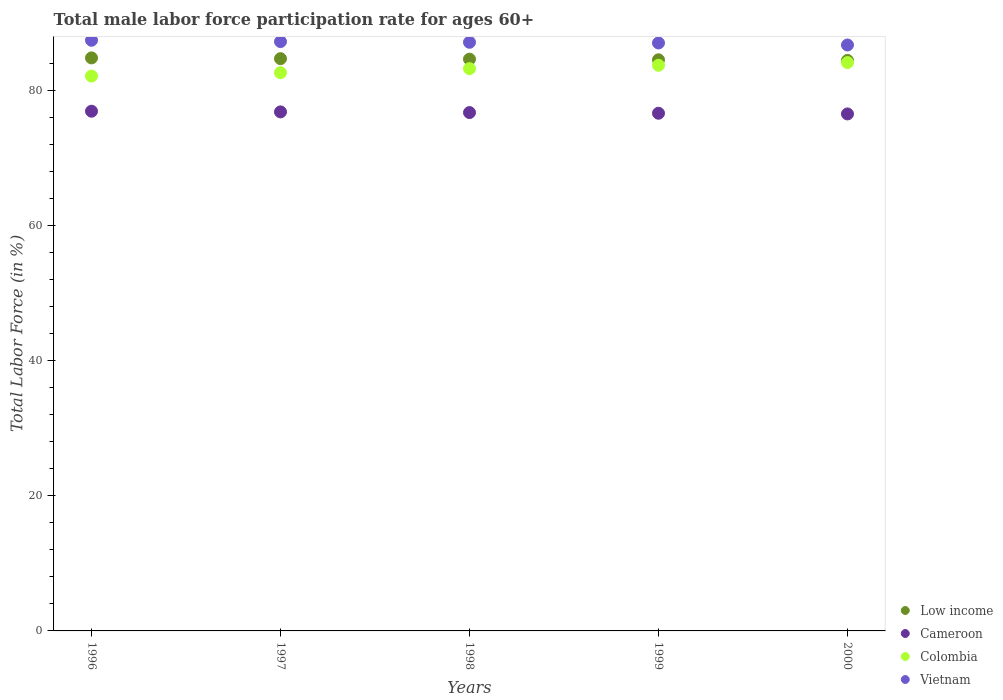How many different coloured dotlines are there?
Your answer should be compact. 4. What is the male labor force participation rate in Vietnam in 2000?
Keep it short and to the point. 86.7. Across all years, what is the maximum male labor force participation rate in Colombia?
Keep it short and to the point. 84.1. Across all years, what is the minimum male labor force participation rate in Vietnam?
Keep it short and to the point. 86.7. In which year was the male labor force participation rate in Low income maximum?
Your answer should be very brief. 1996. In which year was the male labor force participation rate in Cameroon minimum?
Ensure brevity in your answer.  2000. What is the total male labor force participation rate in Cameroon in the graph?
Ensure brevity in your answer.  383.5. What is the difference between the male labor force participation rate in Vietnam in 1997 and that in 1998?
Provide a short and direct response. 0.1. What is the difference between the male labor force participation rate in Vietnam in 1999 and the male labor force participation rate in Cameroon in 1996?
Give a very brief answer. 10.1. What is the average male labor force participation rate in Vietnam per year?
Your answer should be very brief. 87.08. In the year 1996, what is the difference between the male labor force participation rate in Low income and male labor force participation rate in Colombia?
Your answer should be compact. 2.69. What is the ratio of the male labor force participation rate in Low income in 1999 to that in 2000?
Offer a terse response. 1. Is the male labor force participation rate in Vietnam in 1996 less than that in 1999?
Make the answer very short. No. Is the difference between the male labor force participation rate in Low income in 1996 and 1999 greater than the difference between the male labor force participation rate in Colombia in 1996 and 1999?
Offer a very short reply. Yes. What is the difference between the highest and the second highest male labor force participation rate in Low income?
Keep it short and to the point. 0.11. What is the difference between the highest and the lowest male labor force participation rate in Vietnam?
Make the answer very short. 0.7. In how many years, is the male labor force participation rate in Vietnam greater than the average male labor force participation rate in Vietnam taken over all years?
Offer a terse response. 3. Is it the case that in every year, the sum of the male labor force participation rate in Low income and male labor force participation rate in Vietnam  is greater than the sum of male labor force participation rate in Cameroon and male labor force participation rate in Colombia?
Give a very brief answer. Yes. Does the male labor force participation rate in Vietnam monotonically increase over the years?
Make the answer very short. No. Is the male labor force participation rate in Colombia strictly less than the male labor force participation rate in Cameroon over the years?
Your answer should be compact. No. How many years are there in the graph?
Your answer should be very brief. 5. What is the difference between two consecutive major ticks on the Y-axis?
Offer a terse response. 20. Are the values on the major ticks of Y-axis written in scientific E-notation?
Offer a very short reply. No. Does the graph contain any zero values?
Offer a very short reply. No. Does the graph contain grids?
Provide a succinct answer. No. Where does the legend appear in the graph?
Keep it short and to the point. Bottom right. How many legend labels are there?
Offer a terse response. 4. How are the legend labels stacked?
Your answer should be very brief. Vertical. What is the title of the graph?
Provide a succinct answer. Total male labor force participation rate for ages 60+. Does "Guinea" appear as one of the legend labels in the graph?
Provide a succinct answer. No. What is the label or title of the Y-axis?
Offer a very short reply. Total Labor Force (in %). What is the Total Labor Force (in %) in Low income in 1996?
Ensure brevity in your answer.  84.79. What is the Total Labor Force (in %) of Cameroon in 1996?
Keep it short and to the point. 76.9. What is the Total Labor Force (in %) in Colombia in 1996?
Offer a terse response. 82.1. What is the Total Labor Force (in %) in Vietnam in 1996?
Give a very brief answer. 87.4. What is the Total Labor Force (in %) in Low income in 1997?
Your answer should be very brief. 84.68. What is the Total Labor Force (in %) of Cameroon in 1997?
Offer a very short reply. 76.8. What is the Total Labor Force (in %) of Colombia in 1997?
Provide a short and direct response. 82.6. What is the Total Labor Force (in %) in Vietnam in 1997?
Offer a terse response. 87.2. What is the Total Labor Force (in %) of Low income in 1998?
Keep it short and to the point. 84.6. What is the Total Labor Force (in %) of Cameroon in 1998?
Make the answer very short. 76.7. What is the Total Labor Force (in %) in Colombia in 1998?
Provide a succinct answer. 83.2. What is the Total Labor Force (in %) of Vietnam in 1998?
Give a very brief answer. 87.1. What is the Total Labor Force (in %) of Low income in 1999?
Ensure brevity in your answer.  84.51. What is the Total Labor Force (in %) in Cameroon in 1999?
Provide a short and direct response. 76.6. What is the Total Labor Force (in %) in Colombia in 1999?
Provide a short and direct response. 83.7. What is the Total Labor Force (in %) in Low income in 2000?
Provide a short and direct response. 84.42. What is the Total Labor Force (in %) of Cameroon in 2000?
Your answer should be very brief. 76.5. What is the Total Labor Force (in %) of Colombia in 2000?
Your answer should be compact. 84.1. What is the Total Labor Force (in %) of Vietnam in 2000?
Keep it short and to the point. 86.7. Across all years, what is the maximum Total Labor Force (in %) in Low income?
Your answer should be compact. 84.79. Across all years, what is the maximum Total Labor Force (in %) in Cameroon?
Your answer should be compact. 76.9. Across all years, what is the maximum Total Labor Force (in %) in Colombia?
Your answer should be compact. 84.1. Across all years, what is the maximum Total Labor Force (in %) of Vietnam?
Make the answer very short. 87.4. Across all years, what is the minimum Total Labor Force (in %) in Low income?
Your response must be concise. 84.42. Across all years, what is the minimum Total Labor Force (in %) of Cameroon?
Your response must be concise. 76.5. Across all years, what is the minimum Total Labor Force (in %) of Colombia?
Give a very brief answer. 82.1. Across all years, what is the minimum Total Labor Force (in %) of Vietnam?
Offer a terse response. 86.7. What is the total Total Labor Force (in %) of Low income in the graph?
Keep it short and to the point. 423. What is the total Total Labor Force (in %) of Cameroon in the graph?
Provide a succinct answer. 383.5. What is the total Total Labor Force (in %) in Colombia in the graph?
Offer a terse response. 415.7. What is the total Total Labor Force (in %) in Vietnam in the graph?
Make the answer very short. 435.4. What is the difference between the Total Labor Force (in %) in Low income in 1996 and that in 1997?
Provide a succinct answer. 0.11. What is the difference between the Total Labor Force (in %) of Cameroon in 1996 and that in 1997?
Make the answer very short. 0.1. What is the difference between the Total Labor Force (in %) in Colombia in 1996 and that in 1997?
Give a very brief answer. -0.5. What is the difference between the Total Labor Force (in %) of Vietnam in 1996 and that in 1997?
Make the answer very short. 0.2. What is the difference between the Total Labor Force (in %) in Low income in 1996 and that in 1998?
Your answer should be very brief. 0.19. What is the difference between the Total Labor Force (in %) in Cameroon in 1996 and that in 1998?
Make the answer very short. 0.2. What is the difference between the Total Labor Force (in %) in Colombia in 1996 and that in 1998?
Give a very brief answer. -1.1. What is the difference between the Total Labor Force (in %) of Low income in 1996 and that in 1999?
Provide a short and direct response. 0.28. What is the difference between the Total Labor Force (in %) of Low income in 1996 and that in 2000?
Offer a very short reply. 0.37. What is the difference between the Total Labor Force (in %) in Colombia in 1996 and that in 2000?
Offer a terse response. -2. What is the difference between the Total Labor Force (in %) of Low income in 1997 and that in 1998?
Your answer should be very brief. 0.08. What is the difference between the Total Labor Force (in %) in Colombia in 1997 and that in 1998?
Keep it short and to the point. -0.6. What is the difference between the Total Labor Force (in %) in Low income in 1997 and that in 1999?
Give a very brief answer. 0.17. What is the difference between the Total Labor Force (in %) in Low income in 1997 and that in 2000?
Your answer should be compact. 0.26. What is the difference between the Total Labor Force (in %) of Cameroon in 1997 and that in 2000?
Your response must be concise. 0.3. What is the difference between the Total Labor Force (in %) in Low income in 1998 and that in 1999?
Ensure brevity in your answer.  0.09. What is the difference between the Total Labor Force (in %) of Vietnam in 1998 and that in 1999?
Offer a terse response. 0.1. What is the difference between the Total Labor Force (in %) of Low income in 1998 and that in 2000?
Offer a very short reply. 0.19. What is the difference between the Total Labor Force (in %) in Low income in 1999 and that in 2000?
Make the answer very short. 0.09. What is the difference between the Total Labor Force (in %) of Cameroon in 1999 and that in 2000?
Make the answer very short. 0.1. What is the difference between the Total Labor Force (in %) in Vietnam in 1999 and that in 2000?
Ensure brevity in your answer.  0.3. What is the difference between the Total Labor Force (in %) of Low income in 1996 and the Total Labor Force (in %) of Cameroon in 1997?
Give a very brief answer. 7.99. What is the difference between the Total Labor Force (in %) in Low income in 1996 and the Total Labor Force (in %) in Colombia in 1997?
Your response must be concise. 2.19. What is the difference between the Total Labor Force (in %) of Low income in 1996 and the Total Labor Force (in %) of Vietnam in 1997?
Ensure brevity in your answer.  -2.41. What is the difference between the Total Labor Force (in %) of Colombia in 1996 and the Total Labor Force (in %) of Vietnam in 1997?
Make the answer very short. -5.1. What is the difference between the Total Labor Force (in %) in Low income in 1996 and the Total Labor Force (in %) in Cameroon in 1998?
Your response must be concise. 8.09. What is the difference between the Total Labor Force (in %) of Low income in 1996 and the Total Labor Force (in %) of Colombia in 1998?
Make the answer very short. 1.59. What is the difference between the Total Labor Force (in %) in Low income in 1996 and the Total Labor Force (in %) in Vietnam in 1998?
Make the answer very short. -2.31. What is the difference between the Total Labor Force (in %) in Colombia in 1996 and the Total Labor Force (in %) in Vietnam in 1998?
Your answer should be compact. -5. What is the difference between the Total Labor Force (in %) of Low income in 1996 and the Total Labor Force (in %) of Cameroon in 1999?
Make the answer very short. 8.19. What is the difference between the Total Labor Force (in %) of Low income in 1996 and the Total Labor Force (in %) of Colombia in 1999?
Ensure brevity in your answer.  1.09. What is the difference between the Total Labor Force (in %) of Low income in 1996 and the Total Labor Force (in %) of Vietnam in 1999?
Make the answer very short. -2.21. What is the difference between the Total Labor Force (in %) in Cameroon in 1996 and the Total Labor Force (in %) in Colombia in 1999?
Provide a succinct answer. -6.8. What is the difference between the Total Labor Force (in %) of Low income in 1996 and the Total Labor Force (in %) of Cameroon in 2000?
Keep it short and to the point. 8.29. What is the difference between the Total Labor Force (in %) of Low income in 1996 and the Total Labor Force (in %) of Colombia in 2000?
Give a very brief answer. 0.69. What is the difference between the Total Labor Force (in %) in Low income in 1996 and the Total Labor Force (in %) in Vietnam in 2000?
Make the answer very short. -1.91. What is the difference between the Total Labor Force (in %) in Cameroon in 1996 and the Total Labor Force (in %) in Colombia in 2000?
Offer a terse response. -7.2. What is the difference between the Total Labor Force (in %) of Low income in 1997 and the Total Labor Force (in %) of Cameroon in 1998?
Make the answer very short. 7.98. What is the difference between the Total Labor Force (in %) of Low income in 1997 and the Total Labor Force (in %) of Colombia in 1998?
Provide a short and direct response. 1.48. What is the difference between the Total Labor Force (in %) of Low income in 1997 and the Total Labor Force (in %) of Vietnam in 1998?
Offer a terse response. -2.42. What is the difference between the Total Labor Force (in %) in Cameroon in 1997 and the Total Labor Force (in %) in Vietnam in 1998?
Offer a terse response. -10.3. What is the difference between the Total Labor Force (in %) in Colombia in 1997 and the Total Labor Force (in %) in Vietnam in 1998?
Ensure brevity in your answer.  -4.5. What is the difference between the Total Labor Force (in %) in Low income in 1997 and the Total Labor Force (in %) in Cameroon in 1999?
Keep it short and to the point. 8.08. What is the difference between the Total Labor Force (in %) of Low income in 1997 and the Total Labor Force (in %) of Colombia in 1999?
Make the answer very short. 0.98. What is the difference between the Total Labor Force (in %) of Low income in 1997 and the Total Labor Force (in %) of Vietnam in 1999?
Make the answer very short. -2.32. What is the difference between the Total Labor Force (in %) of Cameroon in 1997 and the Total Labor Force (in %) of Colombia in 1999?
Give a very brief answer. -6.9. What is the difference between the Total Labor Force (in %) in Low income in 1997 and the Total Labor Force (in %) in Cameroon in 2000?
Your response must be concise. 8.18. What is the difference between the Total Labor Force (in %) of Low income in 1997 and the Total Labor Force (in %) of Colombia in 2000?
Your answer should be very brief. 0.58. What is the difference between the Total Labor Force (in %) in Low income in 1997 and the Total Labor Force (in %) in Vietnam in 2000?
Offer a very short reply. -2.02. What is the difference between the Total Labor Force (in %) of Cameroon in 1997 and the Total Labor Force (in %) of Vietnam in 2000?
Keep it short and to the point. -9.9. What is the difference between the Total Labor Force (in %) of Colombia in 1997 and the Total Labor Force (in %) of Vietnam in 2000?
Offer a very short reply. -4.1. What is the difference between the Total Labor Force (in %) of Low income in 1998 and the Total Labor Force (in %) of Cameroon in 1999?
Offer a terse response. 8. What is the difference between the Total Labor Force (in %) of Low income in 1998 and the Total Labor Force (in %) of Colombia in 1999?
Your answer should be compact. 0.9. What is the difference between the Total Labor Force (in %) of Low income in 1998 and the Total Labor Force (in %) of Vietnam in 1999?
Your answer should be compact. -2.4. What is the difference between the Total Labor Force (in %) in Cameroon in 1998 and the Total Labor Force (in %) in Colombia in 1999?
Offer a very short reply. -7. What is the difference between the Total Labor Force (in %) of Cameroon in 1998 and the Total Labor Force (in %) of Vietnam in 1999?
Your answer should be very brief. -10.3. What is the difference between the Total Labor Force (in %) of Low income in 1998 and the Total Labor Force (in %) of Cameroon in 2000?
Your answer should be compact. 8.1. What is the difference between the Total Labor Force (in %) of Low income in 1998 and the Total Labor Force (in %) of Colombia in 2000?
Provide a short and direct response. 0.5. What is the difference between the Total Labor Force (in %) of Low income in 1998 and the Total Labor Force (in %) of Vietnam in 2000?
Provide a short and direct response. -2.1. What is the difference between the Total Labor Force (in %) of Cameroon in 1998 and the Total Labor Force (in %) of Colombia in 2000?
Give a very brief answer. -7.4. What is the difference between the Total Labor Force (in %) in Low income in 1999 and the Total Labor Force (in %) in Cameroon in 2000?
Offer a terse response. 8.01. What is the difference between the Total Labor Force (in %) of Low income in 1999 and the Total Labor Force (in %) of Colombia in 2000?
Ensure brevity in your answer.  0.41. What is the difference between the Total Labor Force (in %) of Low income in 1999 and the Total Labor Force (in %) of Vietnam in 2000?
Make the answer very short. -2.19. What is the difference between the Total Labor Force (in %) of Colombia in 1999 and the Total Labor Force (in %) of Vietnam in 2000?
Offer a very short reply. -3. What is the average Total Labor Force (in %) of Low income per year?
Provide a short and direct response. 84.6. What is the average Total Labor Force (in %) of Cameroon per year?
Your response must be concise. 76.7. What is the average Total Labor Force (in %) in Colombia per year?
Provide a short and direct response. 83.14. What is the average Total Labor Force (in %) of Vietnam per year?
Offer a very short reply. 87.08. In the year 1996, what is the difference between the Total Labor Force (in %) in Low income and Total Labor Force (in %) in Cameroon?
Ensure brevity in your answer.  7.89. In the year 1996, what is the difference between the Total Labor Force (in %) in Low income and Total Labor Force (in %) in Colombia?
Provide a short and direct response. 2.69. In the year 1996, what is the difference between the Total Labor Force (in %) of Low income and Total Labor Force (in %) of Vietnam?
Provide a succinct answer. -2.61. In the year 1997, what is the difference between the Total Labor Force (in %) of Low income and Total Labor Force (in %) of Cameroon?
Provide a short and direct response. 7.88. In the year 1997, what is the difference between the Total Labor Force (in %) in Low income and Total Labor Force (in %) in Colombia?
Your response must be concise. 2.08. In the year 1997, what is the difference between the Total Labor Force (in %) in Low income and Total Labor Force (in %) in Vietnam?
Provide a succinct answer. -2.52. In the year 1997, what is the difference between the Total Labor Force (in %) in Colombia and Total Labor Force (in %) in Vietnam?
Your answer should be very brief. -4.6. In the year 1998, what is the difference between the Total Labor Force (in %) of Low income and Total Labor Force (in %) of Cameroon?
Give a very brief answer. 7.9. In the year 1998, what is the difference between the Total Labor Force (in %) of Low income and Total Labor Force (in %) of Colombia?
Keep it short and to the point. 1.4. In the year 1998, what is the difference between the Total Labor Force (in %) of Low income and Total Labor Force (in %) of Vietnam?
Ensure brevity in your answer.  -2.5. In the year 1999, what is the difference between the Total Labor Force (in %) in Low income and Total Labor Force (in %) in Cameroon?
Your answer should be very brief. 7.91. In the year 1999, what is the difference between the Total Labor Force (in %) of Low income and Total Labor Force (in %) of Colombia?
Give a very brief answer. 0.81. In the year 1999, what is the difference between the Total Labor Force (in %) in Low income and Total Labor Force (in %) in Vietnam?
Provide a short and direct response. -2.49. In the year 1999, what is the difference between the Total Labor Force (in %) in Cameroon and Total Labor Force (in %) in Colombia?
Give a very brief answer. -7.1. In the year 1999, what is the difference between the Total Labor Force (in %) of Cameroon and Total Labor Force (in %) of Vietnam?
Offer a very short reply. -10.4. In the year 1999, what is the difference between the Total Labor Force (in %) in Colombia and Total Labor Force (in %) in Vietnam?
Keep it short and to the point. -3.3. In the year 2000, what is the difference between the Total Labor Force (in %) in Low income and Total Labor Force (in %) in Cameroon?
Give a very brief answer. 7.92. In the year 2000, what is the difference between the Total Labor Force (in %) in Low income and Total Labor Force (in %) in Colombia?
Give a very brief answer. 0.32. In the year 2000, what is the difference between the Total Labor Force (in %) of Low income and Total Labor Force (in %) of Vietnam?
Your answer should be very brief. -2.28. In the year 2000, what is the difference between the Total Labor Force (in %) in Cameroon and Total Labor Force (in %) in Colombia?
Offer a very short reply. -7.6. In the year 2000, what is the difference between the Total Labor Force (in %) in Cameroon and Total Labor Force (in %) in Vietnam?
Your response must be concise. -10.2. What is the ratio of the Total Labor Force (in %) in Low income in 1996 to that in 1997?
Offer a terse response. 1. What is the ratio of the Total Labor Force (in %) of Low income in 1996 to that in 1998?
Your response must be concise. 1. What is the ratio of the Total Labor Force (in %) in Cameroon in 1996 to that in 1998?
Keep it short and to the point. 1. What is the ratio of the Total Labor Force (in %) in Colombia in 1996 to that in 1998?
Provide a short and direct response. 0.99. What is the ratio of the Total Labor Force (in %) of Vietnam in 1996 to that in 1998?
Offer a very short reply. 1. What is the ratio of the Total Labor Force (in %) of Cameroon in 1996 to that in 1999?
Ensure brevity in your answer.  1. What is the ratio of the Total Labor Force (in %) in Colombia in 1996 to that in 1999?
Offer a very short reply. 0.98. What is the ratio of the Total Labor Force (in %) in Colombia in 1996 to that in 2000?
Give a very brief answer. 0.98. What is the ratio of the Total Labor Force (in %) of Colombia in 1997 to that in 1998?
Provide a succinct answer. 0.99. What is the ratio of the Total Labor Force (in %) in Vietnam in 1997 to that in 1998?
Your response must be concise. 1. What is the ratio of the Total Labor Force (in %) in Colombia in 1997 to that in 1999?
Provide a succinct answer. 0.99. What is the ratio of the Total Labor Force (in %) of Vietnam in 1997 to that in 1999?
Offer a terse response. 1. What is the ratio of the Total Labor Force (in %) in Low income in 1997 to that in 2000?
Your answer should be compact. 1. What is the ratio of the Total Labor Force (in %) in Cameroon in 1997 to that in 2000?
Your answer should be very brief. 1. What is the ratio of the Total Labor Force (in %) of Colombia in 1997 to that in 2000?
Ensure brevity in your answer.  0.98. What is the ratio of the Total Labor Force (in %) of Low income in 1998 to that in 1999?
Your answer should be very brief. 1. What is the ratio of the Total Labor Force (in %) in Cameroon in 1998 to that in 1999?
Your response must be concise. 1. What is the ratio of the Total Labor Force (in %) in Vietnam in 1998 to that in 1999?
Provide a short and direct response. 1. What is the ratio of the Total Labor Force (in %) of Colombia in 1998 to that in 2000?
Keep it short and to the point. 0.99. What is the ratio of the Total Labor Force (in %) in Vietnam in 1999 to that in 2000?
Keep it short and to the point. 1. What is the difference between the highest and the second highest Total Labor Force (in %) in Low income?
Give a very brief answer. 0.11. What is the difference between the highest and the second highest Total Labor Force (in %) in Cameroon?
Provide a short and direct response. 0.1. What is the difference between the highest and the lowest Total Labor Force (in %) in Low income?
Provide a succinct answer. 0.37. What is the difference between the highest and the lowest Total Labor Force (in %) in Cameroon?
Your answer should be very brief. 0.4. 